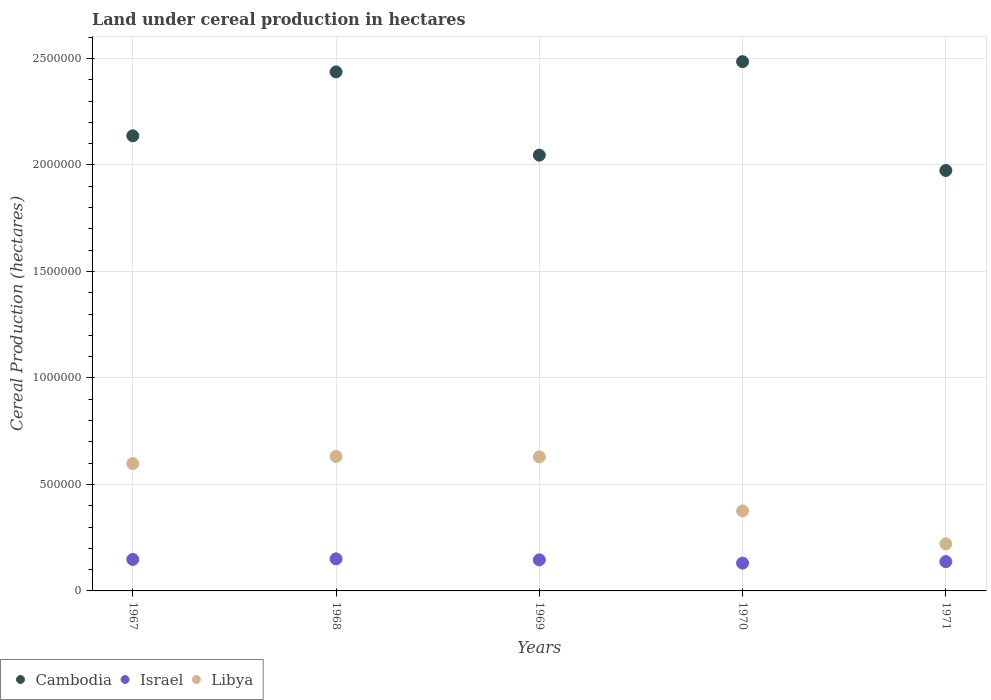How many different coloured dotlines are there?
Your answer should be very brief. 3. What is the land under cereal production in Libya in 1969?
Provide a succinct answer. 6.29e+05. Across all years, what is the maximum land under cereal production in Libya?
Your answer should be very brief. 6.31e+05. Across all years, what is the minimum land under cereal production in Israel?
Keep it short and to the point. 1.31e+05. In which year was the land under cereal production in Israel maximum?
Ensure brevity in your answer.  1968. What is the total land under cereal production in Libya in the graph?
Your response must be concise. 2.46e+06. What is the difference between the land under cereal production in Libya in 1968 and that in 1970?
Make the answer very short. 2.56e+05. What is the difference between the land under cereal production in Libya in 1967 and the land under cereal production in Cambodia in 1968?
Provide a succinct answer. -1.84e+06. What is the average land under cereal production in Libya per year?
Provide a short and direct response. 4.91e+05. In the year 1970, what is the difference between the land under cereal production in Cambodia and land under cereal production in Libya?
Give a very brief answer. 2.11e+06. What is the ratio of the land under cereal production in Cambodia in 1970 to that in 1971?
Your answer should be compact. 1.26. What is the difference between the highest and the second highest land under cereal production in Israel?
Make the answer very short. 2819. What is the difference between the highest and the lowest land under cereal production in Cambodia?
Keep it short and to the point. 5.11e+05. Is the land under cereal production in Libya strictly less than the land under cereal production in Cambodia over the years?
Provide a succinct answer. Yes. How many dotlines are there?
Provide a short and direct response. 3. How many years are there in the graph?
Your answer should be compact. 5. What is the difference between two consecutive major ticks on the Y-axis?
Offer a terse response. 5.00e+05. Are the values on the major ticks of Y-axis written in scientific E-notation?
Your answer should be very brief. No. Does the graph contain any zero values?
Make the answer very short. No. Does the graph contain grids?
Your answer should be compact. Yes. Where does the legend appear in the graph?
Ensure brevity in your answer.  Bottom left. How many legend labels are there?
Your response must be concise. 3. How are the legend labels stacked?
Provide a succinct answer. Horizontal. What is the title of the graph?
Give a very brief answer. Land under cereal production in hectares. Does "World" appear as one of the legend labels in the graph?
Make the answer very short. No. What is the label or title of the X-axis?
Offer a very short reply. Years. What is the label or title of the Y-axis?
Provide a succinct answer. Cereal Production (hectares). What is the Cereal Production (hectares) in Cambodia in 1967?
Offer a very short reply. 2.14e+06. What is the Cereal Production (hectares) in Israel in 1967?
Offer a very short reply. 1.48e+05. What is the Cereal Production (hectares) of Libya in 1967?
Your response must be concise. 5.98e+05. What is the Cereal Production (hectares) of Cambodia in 1968?
Make the answer very short. 2.44e+06. What is the Cereal Production (hectares) of Israel in 1968?
Provide a short and direct response. 1.51e+05. What is the Cereal Production (hectares) in Libya in 1968?
Provide a short and direct response. 6.31e+05. What is the Cereal Production (hectares) in Cambodia in 1969?
Your answer should be very brief. 2.05e+06. What is the Cereal Production (hectares) of Israel in 1969?
Your response must be concise. 1.46e+05. What is the Cereal Production (hectares) in Libya in 1969?
Your response must be concise. 6.29e+05. What is the Cereal Production (hectares) in Cambodia in 1970?
Your answer should be compact. 2.49e+06. What is the Cereal Production (hectares) in Israel in 1970?
Ensure brevity in your answer.  1.31e+05. What is the Cereal Production (hectares) of Libya in 1970?
Provide a succinct answer. 3.76e+05. What is the Cereal Production (hectares) of Cambodia in 1971?
Make the answer very short. 1.97e+06. What is the Cereal Production (hectares) in Israel in 1971?
Offer a terse response. 1.38e+05. What is the Cereal Production (hectares) in Libya in 1971?
Your answer should be compact. 2.21e+05. Across all years, what is the maximum Cereal Production (hectares) in Cambodia?
Give a very brief answer. 2.49e+06. Across all years, what is the maximum Cereal Production (hectares) in Israel?
Make the answer very short. 1.51e+05. Across all years, what is the maximum Cereal Production (hectares) in Libya?
Keep it short and to the point. 6.31e+05. Across all years, what is the minimum Cereal Production (hectares) in Cambodia?
Make the answer very short. 1.97e+06. Across all years, what is the minimum Cereal Production (hectares) of Israel?
Offer a very short reply. 1.31e+05. Across all years, what is the minimum Cereal Production (hectares) of Libya?
Offer a very short reply. 2.21e+05. What is the total Cereal Production (hectares) of Cambodia in the graph?
Provide a short and direct response. 1.11e+07. What is the total Cereal Production (hectares) in Israel in the graph?
Your answer should be compact. 7.13e+05. What is the total Cereal Production (hectares) in Libya in the graph?
Give a very brief answer. 2.46e+06. What is the difference between the Cereal Production (hectares) of Cambodia in 1967 and that in 1968?
Make the answer very short. -3.00e+05. What is the difference between the Cereal Production (hectares) of Israel in 1967 and that in 1968?
Your answer should be compact. -2819. What is the difference between the Cereal Production (hectares) of Libya in 1967 and that in 1968?
Your response must be concise. -3.32e+04. What is the difference between the Cereal Production (hectares) of Cambodia in 1967 and that in 1969?
Offer a terse response. 9.08e+04. What is the difference between the Cereal Production (hectares) of Israel in 1967 and that in 1969?
Provide a succinct answer. 1913. What is the difference between the Cereal Production (hectares) in Libya in 1967 and that in 1969?
Ensure brevity in your answer.  -3.12e+04. What is the difference between the Cereal Production (hectares) in Cambodia in 1967 and that in 1970?
Make the answer very short. -3.48e+05. What is the difference between the Cereal Production (hectares) of Israel in 1967 and that in 1970?
Your response must be concise. 1.71e+04. What is the difference between the Cereal Production (hectares) in Libya in 1967 and that in 1970?
Provide a short and direct response. 2.23e+05. What is the difference between the Cereal Production (hectares) of Cambodia in 1967 and that in 1971?
Your answer should be very brief. 1.63e+05. What is the difference between the Cereal Production (hectares) in Israel in 1967 and that in 1971?
Keep it short and to the point. 1.02e+04. What is the difference between the Cereal Production (hectares) in Libya in 1967 and that in 1971?
Make the answer very short. 3.77e+05. What is the difference between the Cereal Production (hectares) in Cambodia in 1968 and that in 1969?
Keep it short and to the point. 3.91e+05. What is the difference between the Cereal Production (hectares) in Israel in 1968 and that in 1969?
Offer a terse response. 4732. What is the difference between the Cereal Production (hectares) in Libya in 1968 and that in 1969?
Your answer should be compact. 2042. What is the difference between the Cereal Production (hectares) in Cambodia in 1968 and that in 1970?
Your answer should be compact. -4.81e+04. What is the difference between the Cereal Production (hectares) in Israel in 1968 and that in 1970?
Provide a succinct answer. 1.99e+04. What is the difference between the Cereal Production (hectares) in Libya in 1968 and that in 1970?
Ensure brevity in your answer.  2.56e+05. What is the difference between the Cereal Production (hectares) of Cambodia in 1968 and that in 1971?
Provide a succinct answer. 4.63e+05. What is the difference between the Cereal Production (hectares) of Israel in 1968 and that in 1971?
Provide a succinct answer. 1.31e+04. What is the difference between the Cereal Production (hectares) in Libya in 1968 and that in 1971?
Your response must be concise. 4.10e+05. What is the difference between the Cereal Production (hectares) in Cambodia in 1969 and that in 1970?
Keep it short and to the point. -4.39e+05. What is the difference between the Cereal Production (hectares) of Israel in 1969 and that in 1970?
Provide a short and direct response. 1.52e+04. What is the difference between the Cereal Production (hectares) of Libya in 1969 and that in 1970?
Keep it short and to the point. 2.54e+05. What is the difference between the Cereal Production (hectares) in Cambodia in 1969 and that in 1971?
Keep it short and to the point. 7.20e+04. What is the difference between the Cereal Production (hectares) in Israel in 1969 and that in 1971?
Make the answer very short. 8330. What is the difference between the Cereal Production (hectares) in Libya in 1969 and that in 1971?
Make the answer very short. 4.08e+05. What is the difference between the Cereal Production (hectares) in Cambodia in 1970 and that in 1971?
Your answer should be compact. 5.11e+05. What is the difference between the Cereal Production (hectares) of Israel in 1970 and that in 1971?
Your response must be concise. -6880. What is the difference between the Cereal Production (hectares) in Libya in 1970 and that in 1971?
Ensure brevity in your answer.  1.54e+05. What is the difference between the Cereal Production (hectares) of Cambodia in 1967 and the Cereal Production (hectares) of Israel in 1968?
Your answer should be very brief. 1.99e+06. What is the difference between the Cereal Production (hectares) of Cambodia in 1967 and the Cereal Production (hectares) of Libya in 1968?
Your answer should be very brief. 1.51e+06. What is the difference between the Cereal Production (hectares) of Israel in 1967 and the Cereal Production (hectares) of Libya in 1968?
Provide a succinct answer. -4.84e+05. What is the difference between the Cereal Production (hectares) of Cambodia in 1967 and the Cereal Production (hectares) of Israel in 1969?
Keep it short and to the point. 1.99e+06. What is the difference between the Cereal Production (hectares) of Cambodia in 1967 and the Cereal Production (hectares) of Libya in 1969?
Offer a very short reply. 1.51e+06. What is the difference between the Cereal Production (hectares) in Israel in 1967 and the Cereal Production (hectares) in Libya in 1969?
Ensure brevity in your answer.  -4.81e+05. What is the difference between the Cereal Production (hectares) of Cambodia in 1967 and the Cereal Production (hectares) of Israel in 1970?
Offer a very short reply. 2.01e+06. What is the difference between the Cereal Production (hectares) of Cambodia in 1967 and the Cereal Production (hectares) of Libya in 1970?
Offer a very short reply. 1.76e+06. What is the difference between the Cereal Production (hectares) of Israel in 1967 and the Cereal Production (hectares) of Libya in 1970?
Offer a very short reply. -2.28e+05. What is the difference between the Cereal Production (hectares) of Cambodia in 1967 and the Cereal Production (hectares) of Israel in 1971?
Provide a short and direct response. 2.00e+06. What is the difference between the Cereal Production (hectares) of Cambodia in 1967 and the Cereal Production (hectares) of Libya in 1971?
Ensure brevity in your answer.  1.92e+06. What is the difference between the Cereal Production (hectares) in Israel in 1967 and the Cereal Production (hectares) in Libya in 1971?
Your response must be concise. -7.32e+04. What is the difference between the Cereal Production (hectares) of Cambodia in 1968 and the Cereal Production (hectares) of Israel in 1969?
Provide a succinct answer. 2.29e+06. What is the difference between the Cereal Production (hectares) in Cambodia in 1968 and the Cereal Production (hectares) in Libya in 1969?
Ensure brevity in your answer.  1.81e+06. What is the difference between the Cereal Production (hectares) of Israel in 1968 and the Cereal Production (hectares) of Libya in 1969?
Offer a terse response. -4.79e+05. What is the difference between the Cereal Production (hectares) in Cambodia in 1968 and the Cereal Production (hectares) in Israel in 1970?
Provide a succinct answer. 2.31e+06. What is the difference between the Cereal Production (hectares) of Cambodia in 1968 and the Cereal Production (hectares) of Libya in 1970?
Ensure brevity in your answer.  2.06e+06. What is the difference between the Cereal Production (hectares) of Israel in 1968 and the Cereal Production (hectares) of Libya in 1970?
Make the answer very short. -2.25e+05. What is the difference between the Cereal Production (hectares) in Cambodia in 1968 and the Cereal Production (hectares) in Israel in 1971?
Your response must be concise. 2.30e+06. What is the difference between the Cereal Production (hectares) of Cambodia in 1968 and the Cereal Production (hectares) of Libya in 1971?
Make the answer very short. 2.22e+06. What is the difference between the Cereal Production (hectares) in Israel in 1968 and the Cereal Production (hectares) in Libya in 1971?
Offer a terse response. -7.04e+04. What is the difference between the Cereal Production (hectares) in Cambodia in 1969 and the Cereal Production (hectares) in Israel in 1970?
Make the answer very short. 1.92e+06. What is the difference between the Cereal Production (hectares) of Cambodia in 1969 and the Cereal Production (hectares) of Libya in 1970?
Give a very brief answer. 1.67e+06. What is the difference between the Cereal Production (hectares) in Israel in 1969 and the Cereal Production (hectares) in Libya in 1970?
Provide a succinct answer. -2.30e+05. What is the difference between the Cereal Production (hectares) of Cambodia in 1969 and the Cereal Production (hectares) of Israel in 1971?
Keep it short and to the point. 1.91e+06. What is the difference between the Cereal Production (hectares) of Cambodia in 1969 and the Cereal Production (hectares) of Libya in 1971?
Provide a short and direct response. 1.83e+06. What is the difference between the Cereal Production (hectares) in Israel in 1969 and the Cereal Production (hectares) in Libya in 1971?
Provide a short and direct response. -7.51e+04. What is the difference between the Cereal Production (hectares) in Cambodia in 1970 and the Cereal Production (hectares) in Israel in 1971?
Your answer should be compact. 2.35e+06. What is the difference between the Cereal Production (hectares) in Cambodia in 1970 and the Cereal Production (hectares) in Libya in 1971?
Your response must be concise. 2.26e+06. What is the difference between the Cereal Production (hectares) in Israel in 1970 and the Cereal Production (hectares) in Libya in 1971?
Give a very brief answer. -9.04e+04. What is the average Cereal Production (hectares) in Cambodia per year?
Make the answer very short. 2.22e+06. What is the average Cereal Production (hectares) of Israel per year?
Provide a short and direct response. 1.43e+05. What is the average Cereal Production (hectares) of Libya per year?
Keep it short and to the point. 4.91e+05. In the year 1967, what is the difference between the Cereal Production (hectares) of Cambodia and Cereal Production (hectares) of Israel?
Give a very brief answer. 1.99e+06. In the year 1967, what is the difference between the Cereal Production (hectares) of Cambodia and Cereal Production (hectares) of Libya?
Provide a succinct answer. 1.54e+06. In the year 1967, what is the difference between the Cereal Production (hectares) in Israel and Cereal Production (hectares) in Libya?
Offer a very short reply. -4.50e+05. In the year 1968, what is the difference between the Cereal Production (hectares) in Cambodia and Cereal Production (hectares) in Israel?
Keep it short and to the point. 2.29e+06. In the year 1968, what is the difference between the Cereal Production (hectares) in Cambodia and Cereal Production (hectares) in Libya?
Your answer should be very brief. 1.81e+06. In the year 1968, what is the difference between the Cereal Production (hectares) of Israel and Cereal Production (hectares) of Libya?
Offer a terse response. -4.81e+05. In the year 1969, what is the difference between the Cereal Production (hectares) of Cambodia and Cereal Production (hectares) of Israel?
Offer a very short reply. 1.90e+06. In the year 1969, what is the difference between the Cereal Production (hectares) of Cambodia and Cereal Production (hectares) of Libya?
Offer a terse response. 1.42e+06. In the year 1969, what is the difference between the Cereal Production (hectares) in Israel and Cereal Production (hectares) in Libya?
Your answer should be compact. -4.83e+05. In the year 1970, what is the difference between the Cereal Production (hectares) in Cambodia and Cereal Production (hectares) in Israel?
Offer a terse response. 2.35e+06. In the year 1970, what is the difference between the Cereal Production (hectares) in Cambodia and Cereal Production (hectares) in Libya?
Keep it short and to the point. 2.11e+06. In the year 1970, what is the difference between the Cereal Production (hectares) in Israel and Cereal Production (hectares) in Libya?
Offer a very short reply. -2.45e+05. In the year 1971, what is the difference between the Cereal Production (hectares) in Cambodia and Cereal Production (hectares) in Israel?
Provide a short and direct response. 1.84e+06. In the year 1971, what is the difference between the Cereal Production (hectares) of Cambodia and Cereal Production (hectares) of Libya?
Make the answer very short. 1.75e+06. In the year 1971, what is the difference between the Cereal Production (hectares) in Israel and Cereal Production (hectares) in Libya?
Your answer should be very brief. -8.35e+04. What is the ratio of the Cereal Production (hectares) in Cambodia in 1967 to that in 1968?
Your answer should be very brief. 0.88. What is the ratio of the Cereal Production (hectares) in Israel in 1967 to that in 1968?
Ensure brevity in your answer.  0.98. What is the ratio of the Cereal Production (hectares) of Cambodia in 1967 to that in 1969?
Give a very brief answer. 1.04. What is the ratio of the Cereal Production (hectares) of Israel in 1967 to that in 1969?
Your answer should be very brief. 1.01. What is the ratio of the Cereal Production (hectares) in Libya in 1967 to that in 1969?
Make the answer very short. 0.95. What is the ratio of the Cereal Production (hectares) of Cambodia in 1967 to that in 1970?
Ensure brevity in your answer.  0.86. What is the ratio of the Cereal Production (hectares) of Israel in 1967 to that in 1970?
Your answer should be very brief. 1.13. What is the ratio of the Cereal Production (hectares) in Libya in 1967 to that in 1970?
Offer a terse response. 1.59. What is the ratio of the Cereal Production (hectares) of Cambodia in 1967 to that in 1971?
Your answer should be compact. 1.08. What is the ratio of the Cereal Production (hectares) in Israel in 1967 to that in 1971?
Offer a terse response. 1.07. What is the ratio of the Cereal Production (hectares) of Libya in 1967 to that in 1971?
Ensure brevity in your answer.  2.71. What is the ratio of the Cereal Production (hectares) in Cambodia in 1968 to that in 1969?
Provide a succinct answer. 1.19. What is the ratio of the Cereal Production (hectares) in Israel in 1968 to that in 1969?
Ensure brevity in your answer.  1.03. What is the ratio of the Cereal Production (hectares) of Libya in 1968 to that in 1969?
Your answer should be very brief. 1. What is the ratio of the Cereal Production (hectares) in Cambodia in 1968 to that in 1970?
Your answer should be very brief. 0.98. What is the ratio of the Cereal Production (hectares) in Israel in 1968 to that in 1970?
Provide a short and direct response. 1.15. What is the ratio of the Cereal Production (hectares) in Libya in 1968 to that in 1970?
Offer a terse response. 1.68. What is the ratio of the Cereal Production (hectares) of Cambodia in 1968 to that in 1971?
Ensure brevity in your answer.  1.23. What is the ratio of the Cereal Production (hectares) of Israel in 1968 to that in 1971?
Your answer should be very brief. 1.09. What is the ratio of the Cereal Production (hectares) in Libya in 1968 to that in 1971?
Provide a succinct answer. 2.86. What is the ratio of the Cereal Production (hectares) of Cambodia in 1969 to that in 1970?
Keep it short and to the point. 0.82. What is the ratio of the Cereal Production (hectares) in Israel in 1969 to that in 1970?
Your answer should be compact. 1.12. What is the ratio of the Cereal Production (hectares) of Libya in 1969 to that in 1970?
Provide a short and direct response. 1.68. What is the ratio of the Cereal Production (hectares) in Cambodia in 1969 to that in 1971?
Your answer should be very brief. 1.04. What is the ratio of the Cereal Production (hectares) of Israel in 1969 to that in 1971?
Provide a short and direct response. 1.06. What is the ratio of the Cereal Production (hectares) in Libya in 1969 to that in 1971?
Offer a terse response. 2.85. What is the ratio of the Cereal Production (hectares) in Cambodia in 1970 to that in 1971?
Offer a very short reply. 1.26. What is the ratio of the Cereal Production (hectares) of Libya in 1970 to that in 1971?
Offer a terse response. 1.7. What is the difference between the highest and the second highest Cereal Production (hectares) in Cambodia?
Give a very brief answer. 4.81e+04. What is the difference between the highest and the second highest Cereal Production (hectares) of Israel?
Give a very brief answer. 2819. What is the difference between the highest and the second highest Cereal Production (hectares) in Libya?
Make the answer very short. 2042. What is the difference between the highest and the lowest Cereal Production (hectares) in Cambodia?
Offer a terse response. 5.11e+05. What is the difference between the highest and the lowest Cereal Production (hectares) of Israel?
Make the answer very short. 1.99e+04. What is the difference between the highest and the lowest Cereal Production (hectares) of Libya?
Make the answer very short. 4.10e+05. 